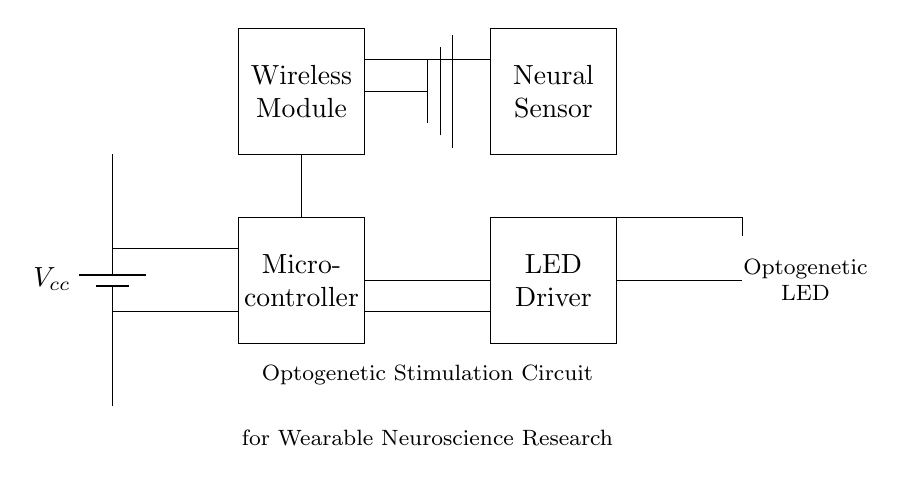What type of LED is used in this circuit? The circuit diagram specifies that the LED used is an "Optogenetic LED," which is indicated in the labeling next to the LED symbol.
Answer: Optogenetic LED What is the purpose of the microcontroller? The microcontroller in the circuit is used to manage and control the signals sent to the LED driver, thereby regulating the optogenetic LED's functioning based on neural sensor inputs or user commands.
Answer: Control signals What component is responsible for wireless communication? The circuit includes a "Wireless Module," which is distinctively labeled in the diagram to indicate its role in managing wireless connections and communications.
Answer: Wireless Module How is the power supplied to this circuit? The circuit shows a "battery" labeled as Vcc, showcasing that the power is supplied from a battery source, with connections detailed leading into the microcontroller and other components.
Answer: Battery What is the connection between the neural sensor and the microcontroller? The diagram indicates a direct connection represented by a line from the "Neural Sensor" to the microcontroller, signifying that the neural sensor provides input data to the microcontroller for processing.
Answer: Direct connection How does the circuit integrate optogenetic stimulation? The circuit integrates optogenetic stimulation by using an optogenetic LED, which can be controlled via signals from the microcontroller based on inputs from the neural sensor, allowing for targeted stimulation of neural tissues.
Answer: Targeted stimulation What type of circuit is depicted in this diagram? The diagram defines the type of circuit as an "Optogenetic Stimulation Circuit," which explicitly indicates its specific use in wearable neuroscience research applications by the labeling at the bottom.
Answer: Optogenetic Stimulation Circuit 